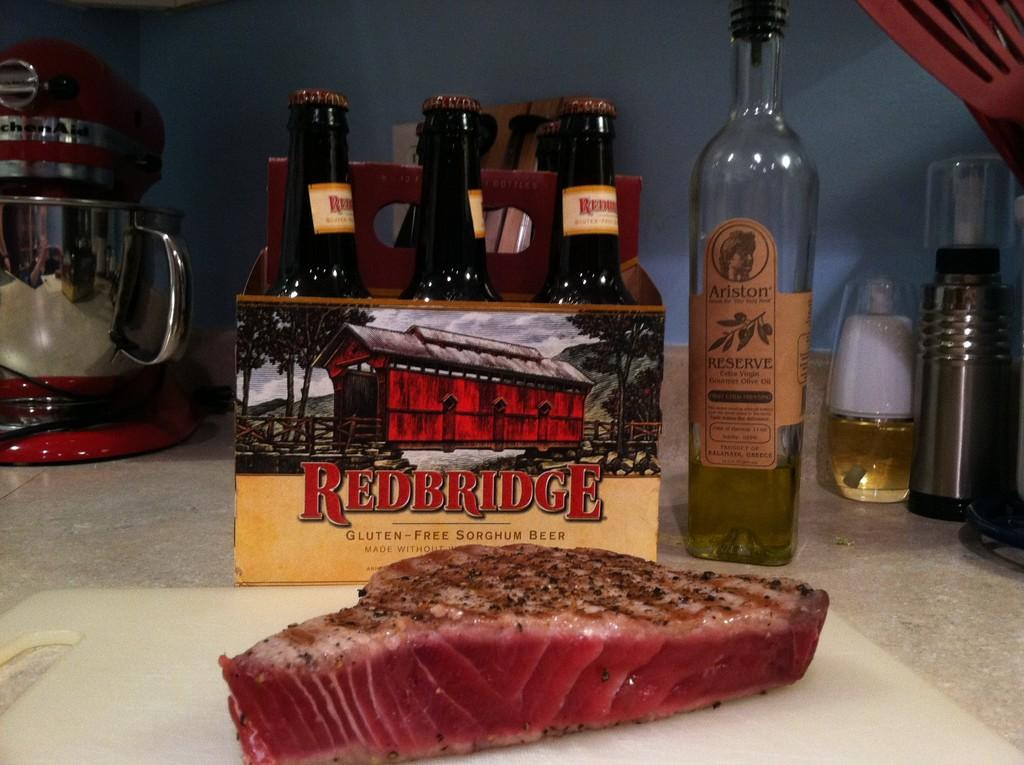What type of food can be seen in the image? There is meat in the image. What seasoning is visible in the image? Pepper powder is present in the image. Where are the bottles located in the image? There are bottles in a box and on the table in the image. What kitchen appliance is in the image? There is a kettle in the image. What can be seen in the background of the image? There is a wall in the background of the image. What type of voyage is depicted in the image? There is no voyage depicted in the image; it features food items, seasoning, bottles, a kettle, and a wall. Who is the representative in the image? There is no representative present in the image. 